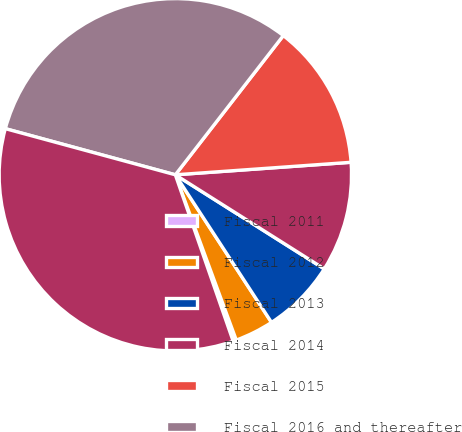<chart> <loc_0><loc_0><loc_500><loc_500><pie_chart><fcel>Fiscal 2011<fcel>Fiscal 2012<fcel>Fiscal 2013<fcel>Fiscal 2014<fcel>Fiscal 2015<fcel>Fiscal 2016 and thereafter<fcel>Total<nl><fcel>0.3%<fcel>3.57%<fcel>6.84%<fcel>10.1%<fcel>13.37%<fcel>31.28%<fcel>34.54%<nl></chart> 